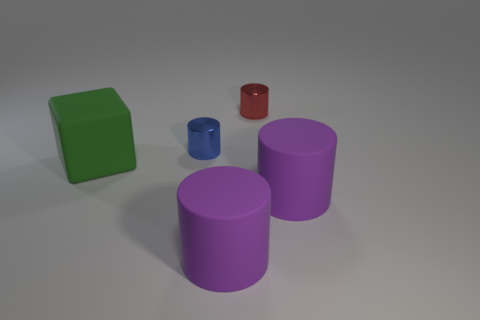Add 3 small blue shiny things. How many objects exist? 8 Subtract all blocks. How many objects are left? 4 Subtract 0 blue balls. How many objects are left? 5 Subtract all tiny red things. Subtract all green metal cubes. How many objects are left? 4 Add 1 cubes. How many cubes are left? 2 Add 3 small cyan matte things. How many small cyan matte things exist? 3 